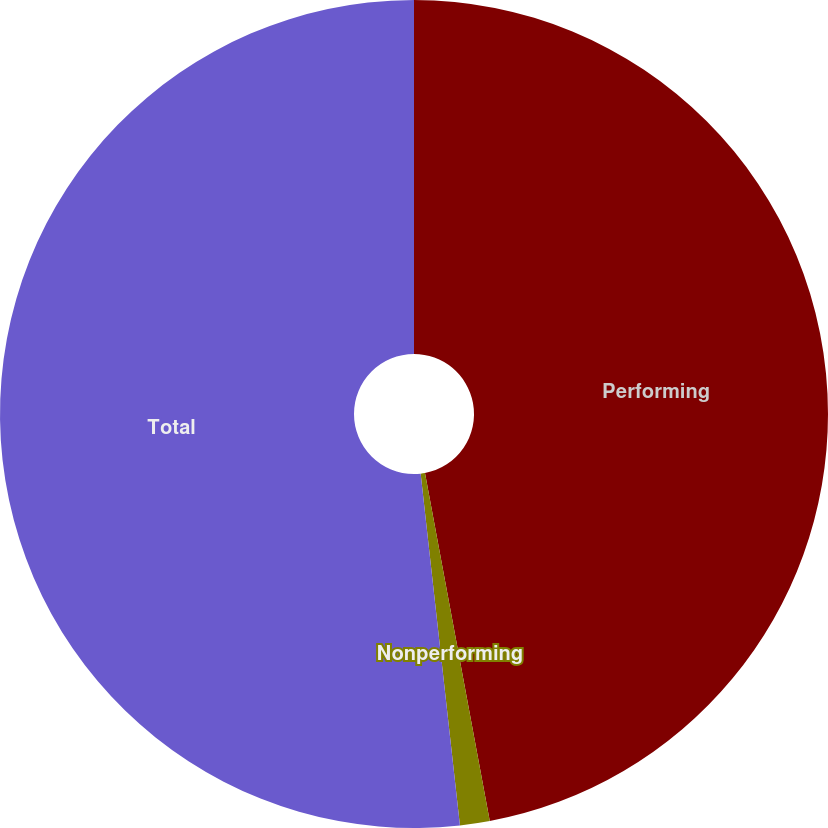<chart> <loc_0><loc_0><loc_500><loc_500><pie_chart><fcel>Performing<fcel>Nonperforming<fcel>Total<nl><fcel>47.07%<fcel>1.16%<fcel>51.77%<nl></chart> 